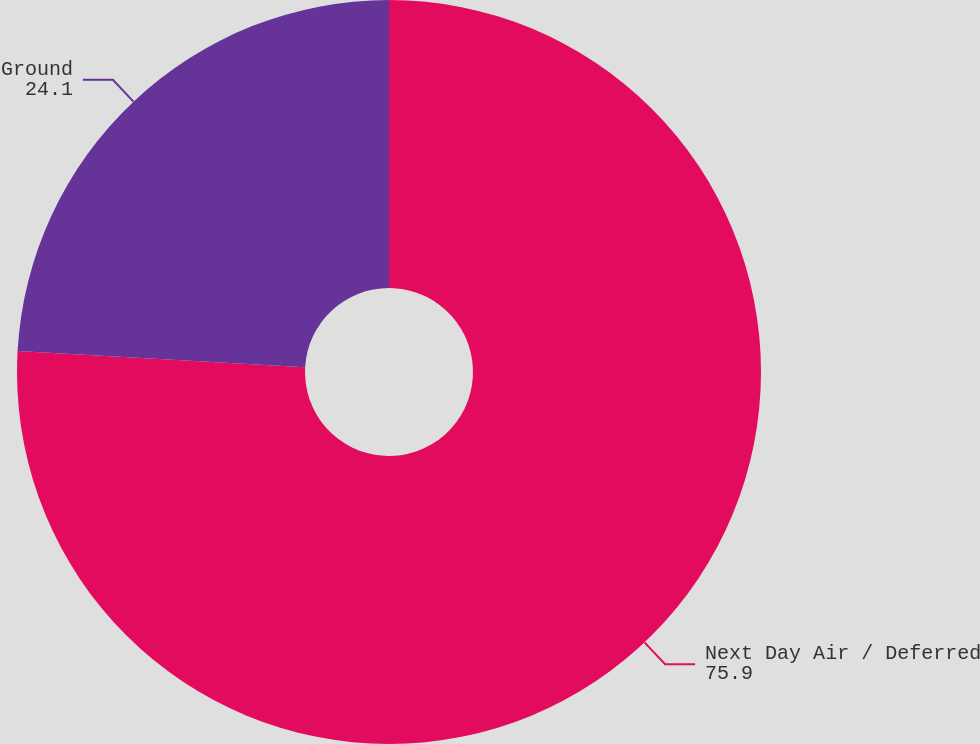<chart> <loc_0><loc_0><loc_500><loc_500><pie_chart><fcel>Next Day Air / Deferred<fcel>Ground<nl><fcel>75.9%<fcel>24.1%<nl></chart> 